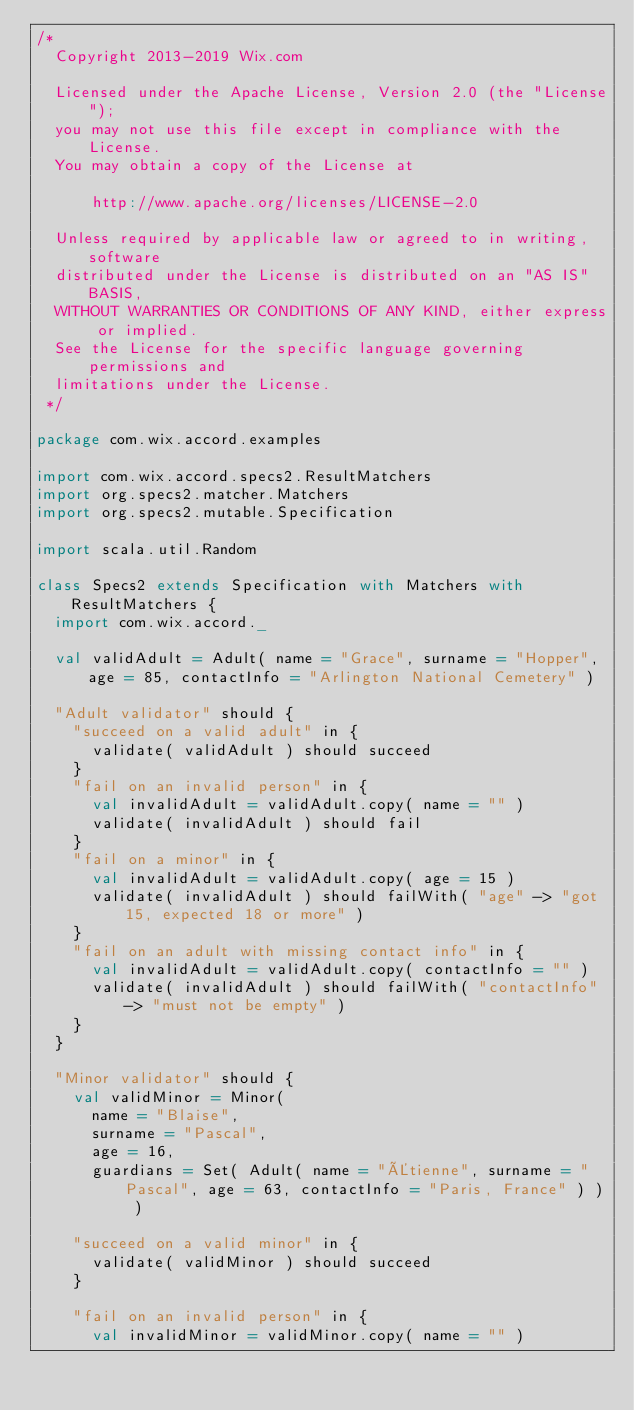<code> <loc_0><loc_0><loc_500><loc_500><_Scala_>/*
  Copyright 2013-2019 Wix.com

  Licensed under the Apache License, Version 2.0 (the "License");
  you may not use this file except in compliance with the License.
  You may obtain a copy of the License at

      http://www.apache.org/licenses/LICENSE-2.0

  Unless required by applicable law or agreed to in writing, software
  distributed under the License is distributed on an "AS IS" BASIS,
  WITHOUT WARRANTIES OR CONDITIONS OF ANY KIND, either express or implied.
  See the License for the specific language governing permissions and
  limitations under the License.
 */

package com.wix.accord.examples

import com.wix.accord.specs2.ResultMatchers
import org.specs2.matcher.Matchers
import org.specs2.mutable.Specification

import scala.util.Random

class Specs2 extends Specification with Matchers with ResultMatchers {
  import com.wix.accord._

  val validAdult = Adult( name = "Grace", surname = "Hopper", age = 85, contactInfo = "Arlington National Cemetery" )

  "Adult validator" should {
    "succeed on a valid adult" in {
      validate( validAdult ) should succeed
    }
    "fail on an invalid person" in {
      val invalidAdult = validAdult.copy( name = "" )
      validate( invalidAdult ) should fail
    }
    "fail on a minor" in {
      val invalidAdult = validAdult.copy( age = 15 )
      validate( invalidAdult ) should failWith( "age" -> "got 15, expected 18 or more" )
    }
    "fail on an adult with missing contact info" in {
      val invalidAdult = validAdult.copy( contactInfo = "" )
      validate( invalidAdult ) should failWith( "contactInfo" -> "must not be empty" )
    }
  }

  "Minor validator" should {
    val validMinor = Minor(
      name = "Blaise",
      surname = "Pascal",
      age = 16,
      guardians = Set( Adult( name = "Étienne", surname = "Pascal", age = 63, contactInfo = "Paris, France" ) ) )

    "succeed on a valid minor" in {
      validate( validMinor ) should succeed
    }

    "fail on an invalid person" in {
      val invalidMinor = validMinor.copy( name = "" )</code> 